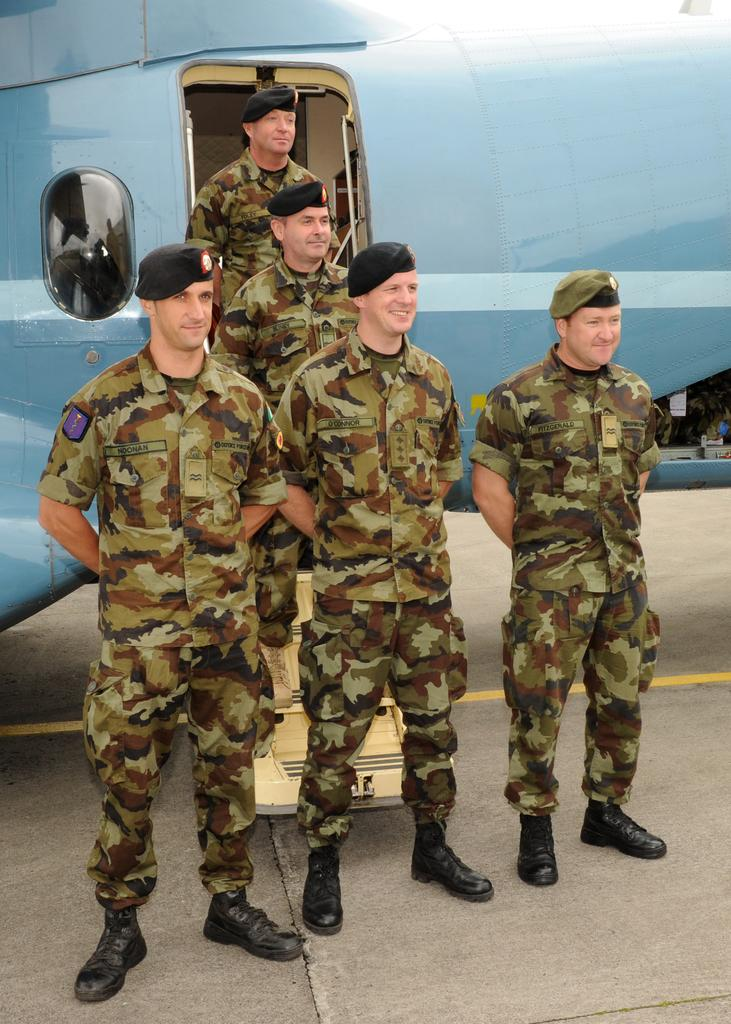How many people are in the image? There is a group of people in the image, but the exact number is not specified. What are the people wearing on their heads? The people are wearing caps in the image. What can be seen in the background behind the group of people? There is a plane visible behind the group of people. What type of cloth is being used to clean the throat of the person in the image? There is no person in the image having their throat cleaned, nor is there any cloth present. 